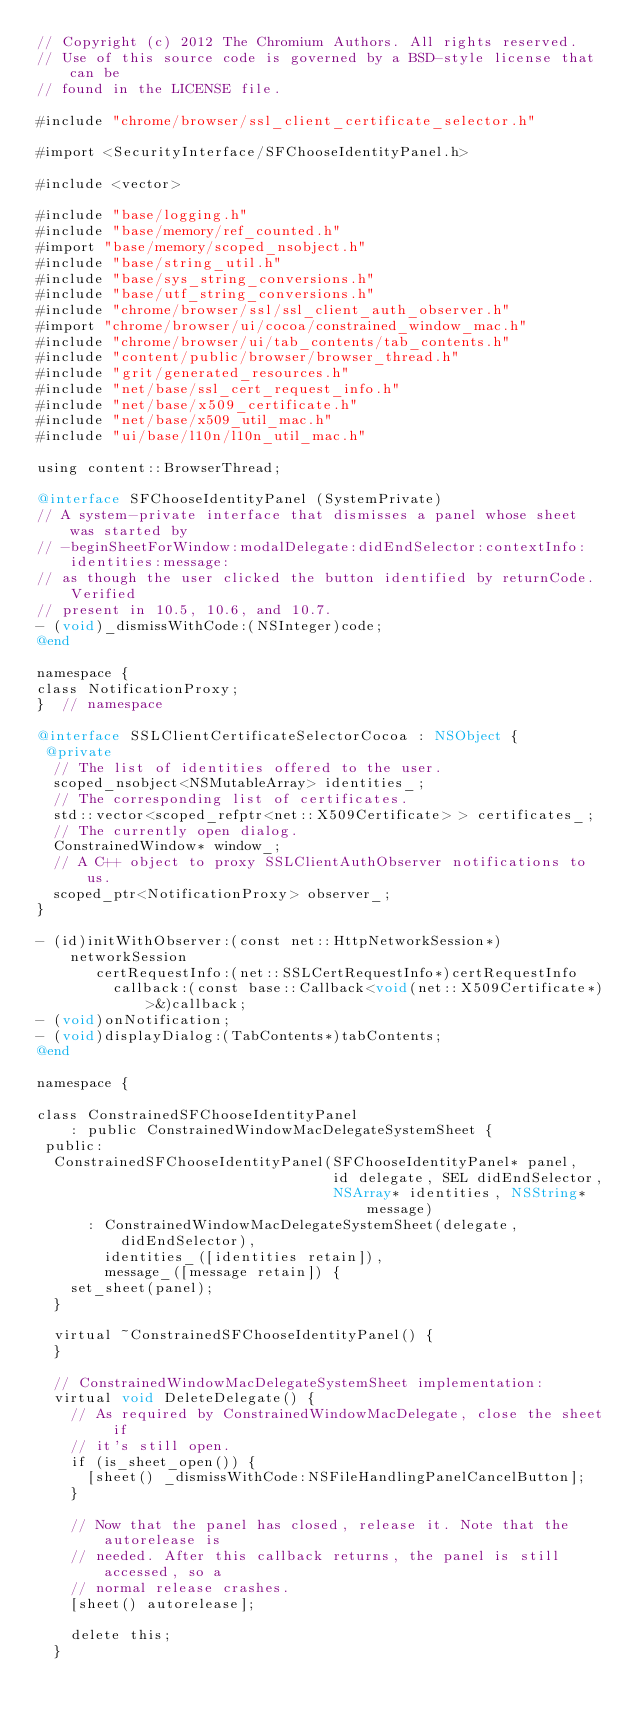Convert code to text. <code><loc_0><loc_0><loc_500><loc_500><_ObjectiveC_>// Copyright (c) 2012 The Chromium Authors. All rights reserved.
// Use of this source code is governed by a BSD-style license that can be
// found in the LICENSE file.

#include "chrome/browser/ssl_client_certificate_selector.h"

#import <SecurityInterface/SFChooseIdentityPanel.h>

#include <vector>

#include "base/logging.h"
#include "base/memory/ref_counted.h"
#import "base/memory/scoped_nsobject.h"
#include "base/string_util.h"
#include "base/sys_string_conversions.h"
#include "base/utf_string_conversions.h"
#include "chrome/browser/ssl/ssl_client_auth_observer.h"
#import "chrome/browser/ui/cocoa/constrained_window_mac.h"
#include "chrome/browser/ui/tab_contents/tab_contents.h"
#include "content/public/browser/browser_thread.h"
#include "grit/generated_resources.h"
#include "net/base/ssl_cert_request_info.h"
#include "net/base/x509_certificate.h"
#include "net/base/x509_util_mac.h"
#include "ui/base/l10n/l10n_util_mac.h"

using content::BrowserThread;

@interface SFChooseIdentityPanel (SystemPrivate)
// A system-private interface that dismisses a panel whose sheet was started by
// -beginSheetForWindow:modalDelegate:didEndSelector:contextInfo:identities:message:
// as though the user clicked the button identified by returnCode. Verified
// present in 10.5, 10.6, and 10.7.
- (void)_dismissWithCode:(NSInteger)code;
@end

namespace {
class NotificationProxy;
}  // namespace

@interface SSLClientCertificateSelectorCocoa : NSObject {
 @private
  // The list of identities offered to the user.
  scoped_nsobject<NSMutableArray> identities_;
  // The corresponding list of certificates.
  std::vector<scoped_refptr<net::X509Certificate> > certificates_;
  // The currently open dialog.
  ConstrainedWindow* window_;
  // A C++ object to proxy SSLClientAuthObserver notifications to us.
  scoped_ptr<NotificationProxy> observer_;
}

- (id)initWithObserver:(const net::HttpNetworkSession*)networkSession
       certRequestInfo:(net::SSLCertRequestInfo*)certRequestInfo
         callback:(const base::Callback<void(net::X509Certificate*)>&)callback;
- (void)onNotification;
- (void)displayDialog:(TabContents*)tabContents;
@end

namespace {

class ConstrainedSFChooseIdentityPanel
    : public ConstrainedWindowMacDelegateSystemSheet {
 public:
  ConstrainedSFChooseIdentityPanel(SFChooseIdentityPanel* panel,
                                   id delegate, SEL didEndSelector,
                                   NSArray* identities, NSString* message)
      : ConstrainedWindowMacDelegateSystemSheet(delegate, didEndSelector),
        identities_([identities retain]),
        message_([message retain]) {
    set_sheet(panel);
  }

  virtual ~ConstrainedSFChooseIdentityPanel() {
  }

  // ConstrainedWindowMacDelegateSystemSheet implementation:
  virtual void DeleteDelegate() {
    // As required by ConstrainedWindowMacDelegate, close the sheet if
    // it's still open.
    if (is_sheet_open()) {
      [sheet() _dismissWithCode:NSFileHandlingPanelCancelButton];
    }

    // Now that the panel has closed, release it. Note that the autorelease is
    // needed. After this callback returns, the panel is still accessed, so a
    // normal release crashes.
    [sheet() autorelease];

    delete this;
  }
</code> 